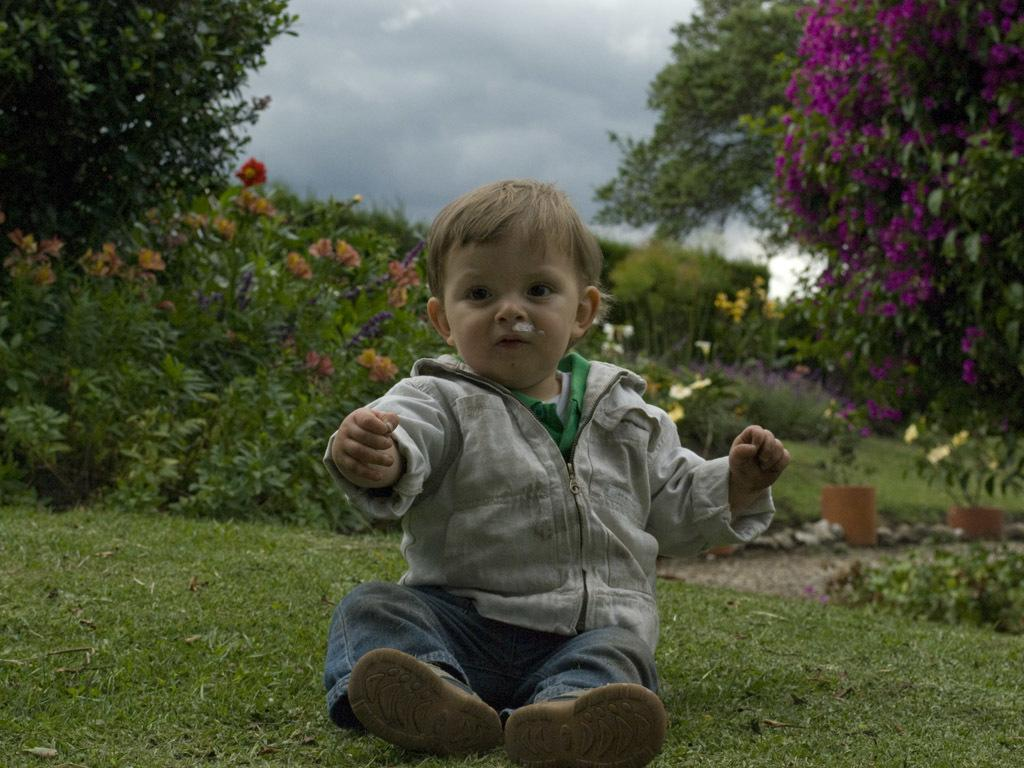What is the main subject in the foreground of the image? There is a boy sitting on the grass in the foreground of the image. What can be seen in the background of the image? There are plants, trees, flowers, and a cloud visible in the background of the image. What type of guide is helping the boy in the image? There is no guide present in the image; the boy is sitting on the grass by himself. 